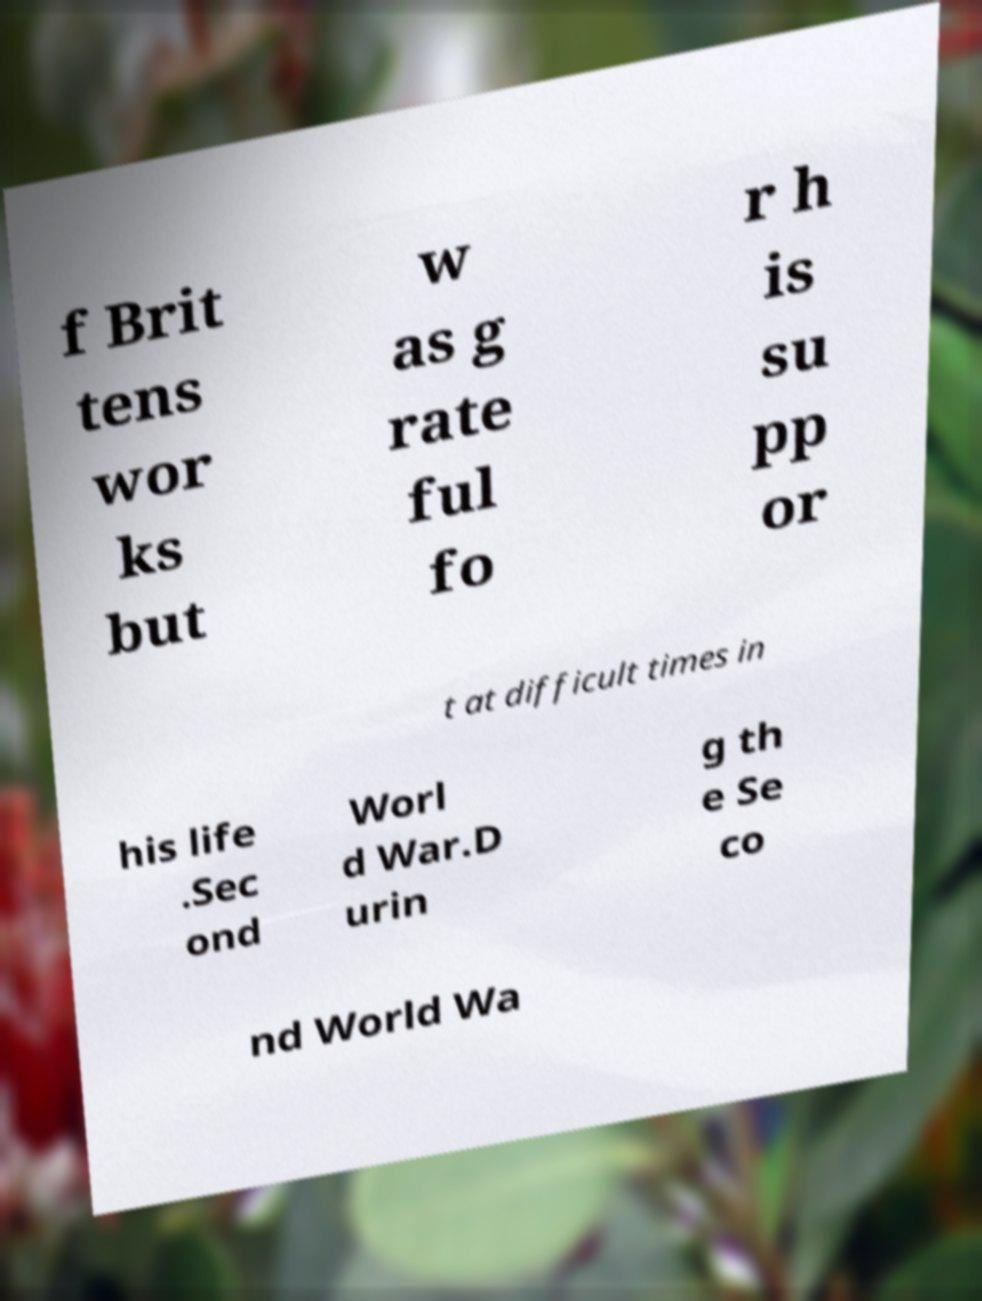Can you read and provide the text displayed in the image?This photo seems to have some interesting text. Can you extract and type it out for me? f Brit tens wor ks but w as g rate ful fo r h is su pp or t at difficult times in his life .Sec ond Worl d War.D urin g th e Se co nd World Wa 